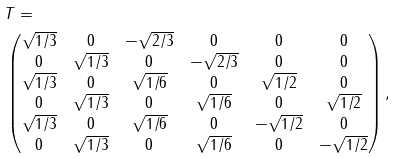Convert formula to latex. <formula><loc_0><loc_0><loc_500><loc_500>& T = \\ & \begin{pmatrix} \sqrt { 1 / 3 } & 0 & - \sqrt { 2 / 3 } & 0 & 0 & 0 \\ 0 & \sqrt { 1 / 3 } & 0 & - \sqrt { 2 / 3 } & 0 & 0 \\ \sqrt { 1 / 3 } & 0 & \sqrt { 1 / 6 } & 0 & \sqrt { 1 / 2 } & 0 \\ 0 & \sqrt { 1 / 3 } & 0 & \sqrt { 1 / 6 } & 0 & \sqrt { 1 / 2 } \\ \sqrt { 1 / 3 } & 0 & \sqrt { 1 / 6 } & 0 & - \sqrt { 1 / 2 } & 0 \\ 0 & \sqrt { 1 / 3 } & 0 & \sqrt { 1 / 6 } & 0 & - \sqrt { 1 / 2 } \\ \end{pmatrix} ,</formula> 